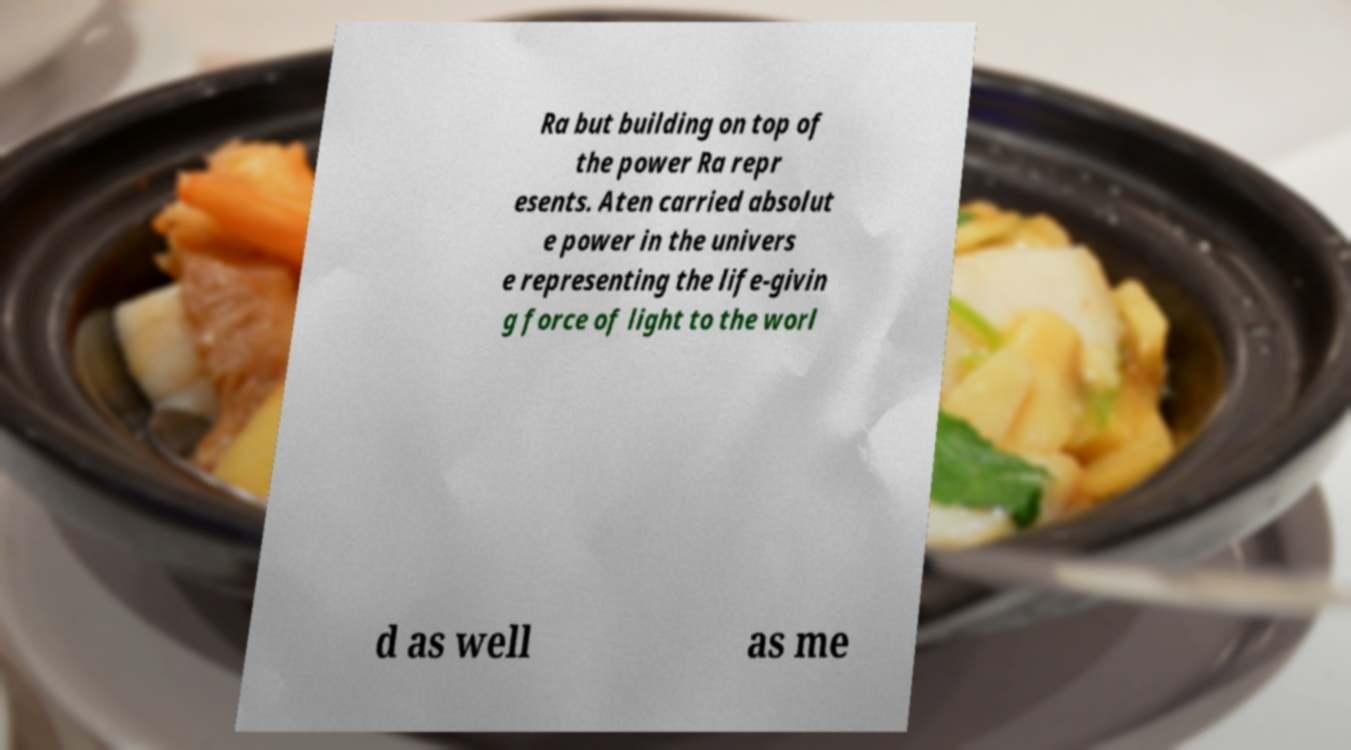There's text embedded in this image that I need extracted. Can you transcribe it verbatim? Ra but building on top of the power Ra repr esents. Aten carried absolut e power in the univers e representing the life-givin g force of light to the worl d as well as me 